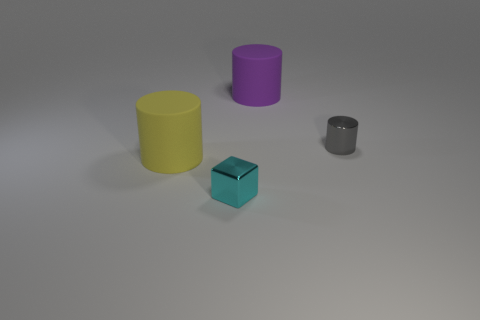Subtract all yellow cylinders. Subtract all purple cubes. How many cylinders are left? 2 Add 4 big brown shiny spheres. How many objects exist? 8 Subtract all cubes. How many objects are left? 3 Add 1 tiny blue metal blocks. How many tiny blue metal blocks exist? 1 Subtract 0 green balls. How many objects are left? 4 Subtract all rubber cylinders. Subtract all tiny gray cylinders. How many objects are left? 1 Add 3 yellow matte cylinders. How many yellow matte cylinders are left? 4 